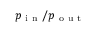Convert formula to latex. <formula><loc_0><loc_0><loc_500><loc_500>p _ { i n } / p _ { o u t }</formula> 